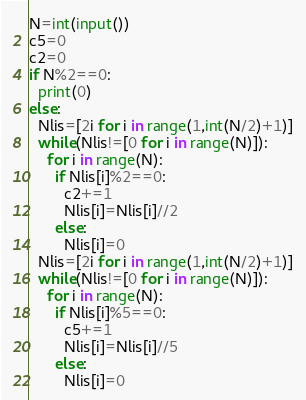<code> <loc_0><loc_0><loc_500><loc_500><_Python_>N=int(input())
c5=0
c2=0
if N%2==0:
  print(0)
else:
  Nlis=[2i for i in range(1,int(N/2)+1)]
  while(Nlis!=[0 for i in range(N)]):
    for i in range(N):
      if Nlis[i]%2==0:
        c2+=1
        Nlis[i]=Nlis[i]//2
      else:
        Nlis[i]=0
  Nlis=[2i for i in range(1,int(N/2)+1)]
  while(Nlis!=[0 for i in range(N)]):
    for i in range(N):
      if Nlis[i]%5==0:
        c5+=1
        Nlis[i]=Nlis[i]//5
      else:
        Nlis[i]=0
</code> 